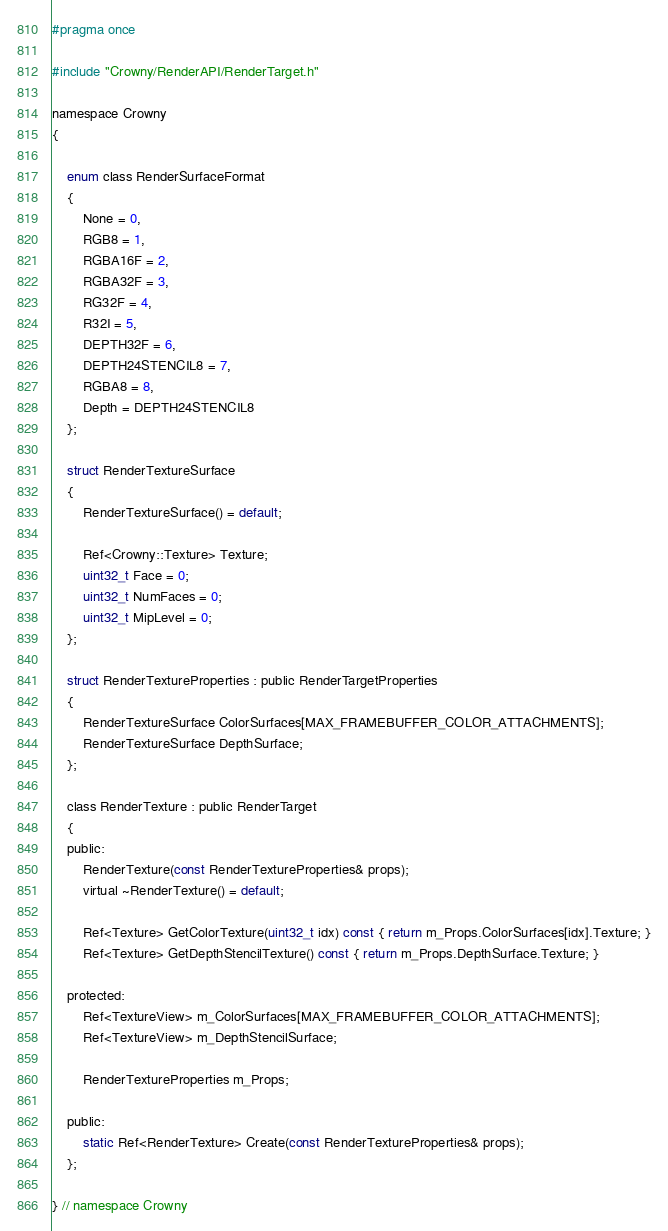Convert code to text. <code><loc_0><loc_0><loc_500><loc_500><_C_>#pragma once

#include "Crowny/RenderAPI/RenderTarget.h"

namespace Crowny
{

    enum class RenderSurfaceFormat
    {
        None = 0,
        RGB8 = 1,
        RGBA16F = 2,
        RGBA32F = 3,
        RG32F = 4,
        R32I = 5,
        DEPTH32F = 6,
        DEPTH24STENCIL8 = 7,
        RGBA8 = 8,
        Depth = DEPTH24STENCIL8
    };

    struct RenderTextureSurface
    {
        RenderTextureSurface() = default;

        Ref<Crowny::Texture> Texture;
        uint32_t Face = 0;
        uint32_t NumFaces = 0;
        uint32_t MipLevel = 0;
    };

    struct RenderTextureProperties : public RenderTargetProperties
    {
        RenderTextureSurface ColorSurfaces[MAX_FRAMEBUFFER_COLOR_ATTACHMENTS];
        RenderTextureSurface DepthSurface;
    };

    class RenderTexture : public RenderTarget
    {
    public:
        RenderTexture(const RenderTextureProperties& props);
        virtual ~RenderTexture() = default;

        Ref<Texture> GetColorTexture(uint32_t idx) const { return m_Props.ColorSurfaces[idx].Texture; }
        Ref<Texture> GetDepthStencilTexture() const { return m_Props.DepthSurface.Texture; }

    protected:
        Ref<TextureView> m_ColorSurfaces[MAX_FRAMEBUFFER_COLOR_ATTACHMENTS];
        Ref<TextureView> m_DepthStencilSurface;

        RenderTextureProperties m_Props;

    public:
        static Ref<RenderTexture> Create(const RenderTextureProperties& props);
    };

} // namespace Crowny</code> 